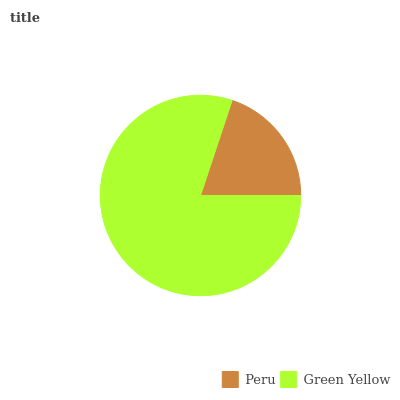Is Peru the minimum?
Answer yes or no. Yes. Is Green Yellow the maximum?
Answer yes or no. Yes. Is Green Yellow the minimum?
Answer yes or no. No. Is Green Yellow greater than Peru?
Answer yes or no. Yes. Is Peru less than Green Yellow?
Answer yes or no. Yes. Is Peru greater than Green Yellow?
Answer yes or no. No. Is Green Yellow less than Peru?
Answer yes or no. No. Is Green Yellow the high median?
Answer yes or no. Yes. Is Peru the low median?
Answer yes or no. Yes. Is Peru the high median?
Answer yes or no. No. Is Green Yellow the low median?
Answer yes or no. No. 